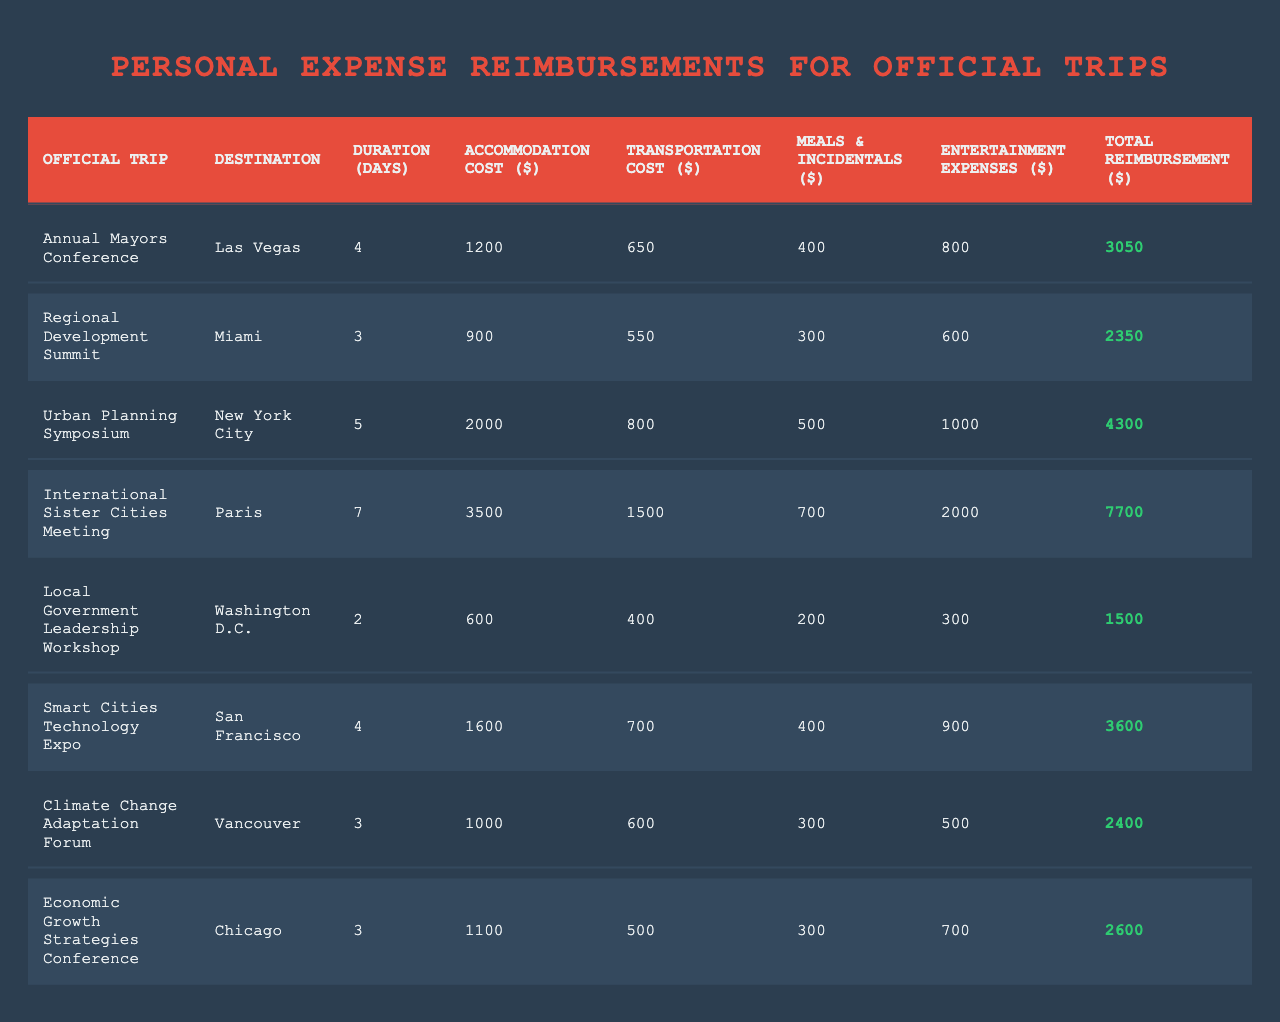What is the total reimbursement for the International Sister Cities Meeting? The table lists the total reimbursement for the International Sister Cities Meeting as $7700.
Answer: $7700 Which trip incurred the highest accommodation cost? The trip with the highest accommodation cost is the International Sister Cities Meeting at $3500.
Answer: International Sister Cities Meeting What is the average transportation cost across all trips? To find the average, we first sum the transportation costs: 650 + 550 + 800 + 1500 + 400 + 700 + 600 + 500 = 4750. There are 8 trips, so the average transportation cost is 4750 / 8 = 593.75.
Answer: 593.75 Is the total reimbursement for the Urban Planning Symposium greater than $4000? Yes, the total reimbursement for the Urban Planning Symposium is $4300, which is greater than $4000.
Answer: Yes What is the total amount spent on entertainment expenses for all trips combined? The total spent on entertainment expenses is calculated by summing: 800 + 600 + 1000 + 2000 + 300 + 900 + 500 + 700 = 6100.
Answer: $6100 Which trip had the lowest total reimbursement? The trip with the lowest total reimbursement is the Local Government Leadership Workshop, which totaled $1500.
Answer: Local Government Leadership Workshop If you sum the duration of all trips, what is the total duration in days? The total duration is calculated by adding the number of days for each trip: 4 + 3 + 5 + 7 + 2 + 4 + 3 + 3 = 31 days.
Answer: 31 days For which trip was the transportation cost the least? The trip with the least transportation cost is the Local Government Leadership Workshop, which cost $400.
Answer: Local Government Leadership Workshop What percentage of the total reimbursement for the Annual Mayors Conference is made up by accommodation costs? The percentage is calculated by taking the accommodation cost of $1200 divided by the total reimbursement of $3050, which gives (1200 / 3050) * 100 ≈ 39.34%.
Answer: Approximately 39.34% Identify the trip with the longest duration and its total reimbursement. The trip with the longest duration is the International Sister Cities Meeting, lasting 7 days, with a total reimbursement of $7700.
Answer: 7 days and $7700 